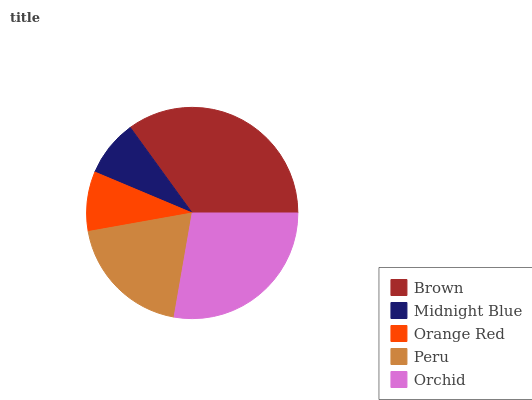Is Midnight Blue the minimum?
Answer yes or no. Yes. Is Brown the maximum?
Answer yes or no. Yes. Is Orange Red the minimum?
Answer yes or no. No. Is Orange Red the maximum?
Answer yes or no. No. Is Orange Red greater than Midnight Blue?
Answer yes or no. Yes. Is Midnight Blue less than Orange Red?
Answer yes or no. Yes. Is Midnight Blue greater than Orange Red?
Answer yes or no. No. Is Orange Red less than Midnight Blue?
Answer yes or no. No. Is Peru the high median?
Answer yes or no. Yes. Is Peru the low median?
Answer yes or no. Yes. Is Midnight Blue the high median?
Answer yes or no. No. Is Midnight Blue the low median?
Answer yes or no. No. 